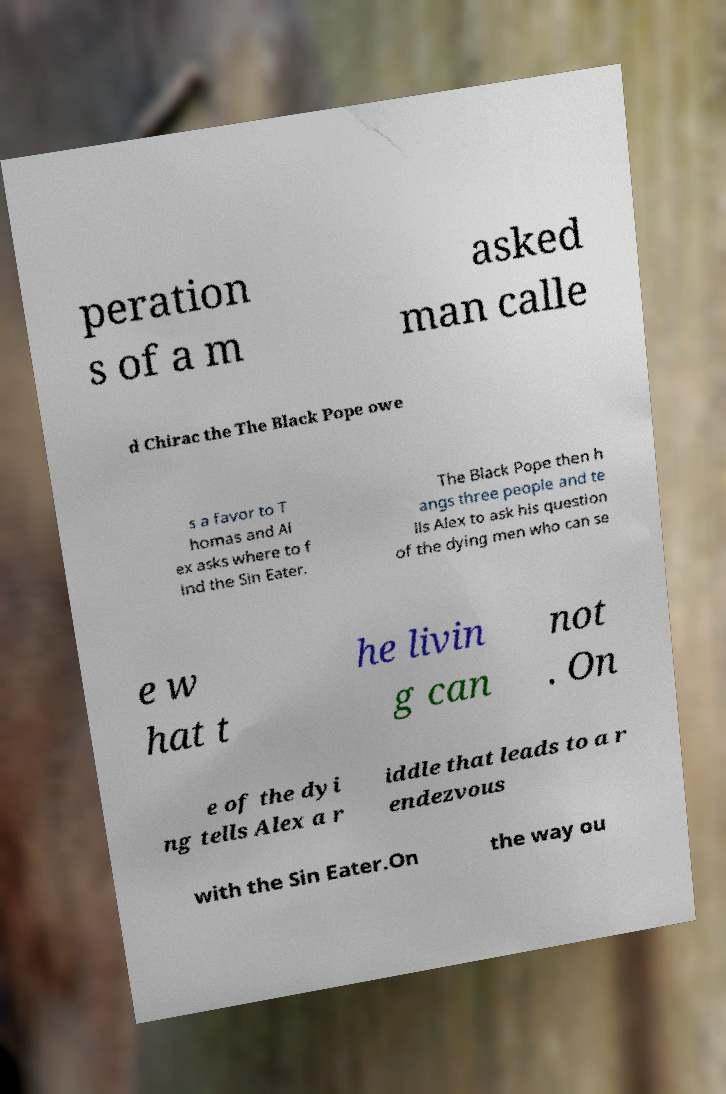Can you read and provide the text displayed in the image?This photo seems to have some interesting text. Can you extract and type it out for me? peration s of a m asked man calle d Chirac the The Black Pope owe s a favor to T homas and Al ex asks where to f ind the Sin Eater. The Black Pope then h angs three people and te lls Alex to ask his question of the dying men who can se e w hat t he livin g can not . On e of the dyi ng tells Alex a r iddle that leads to a r endezvous with the Sin Eater.On the way ou 